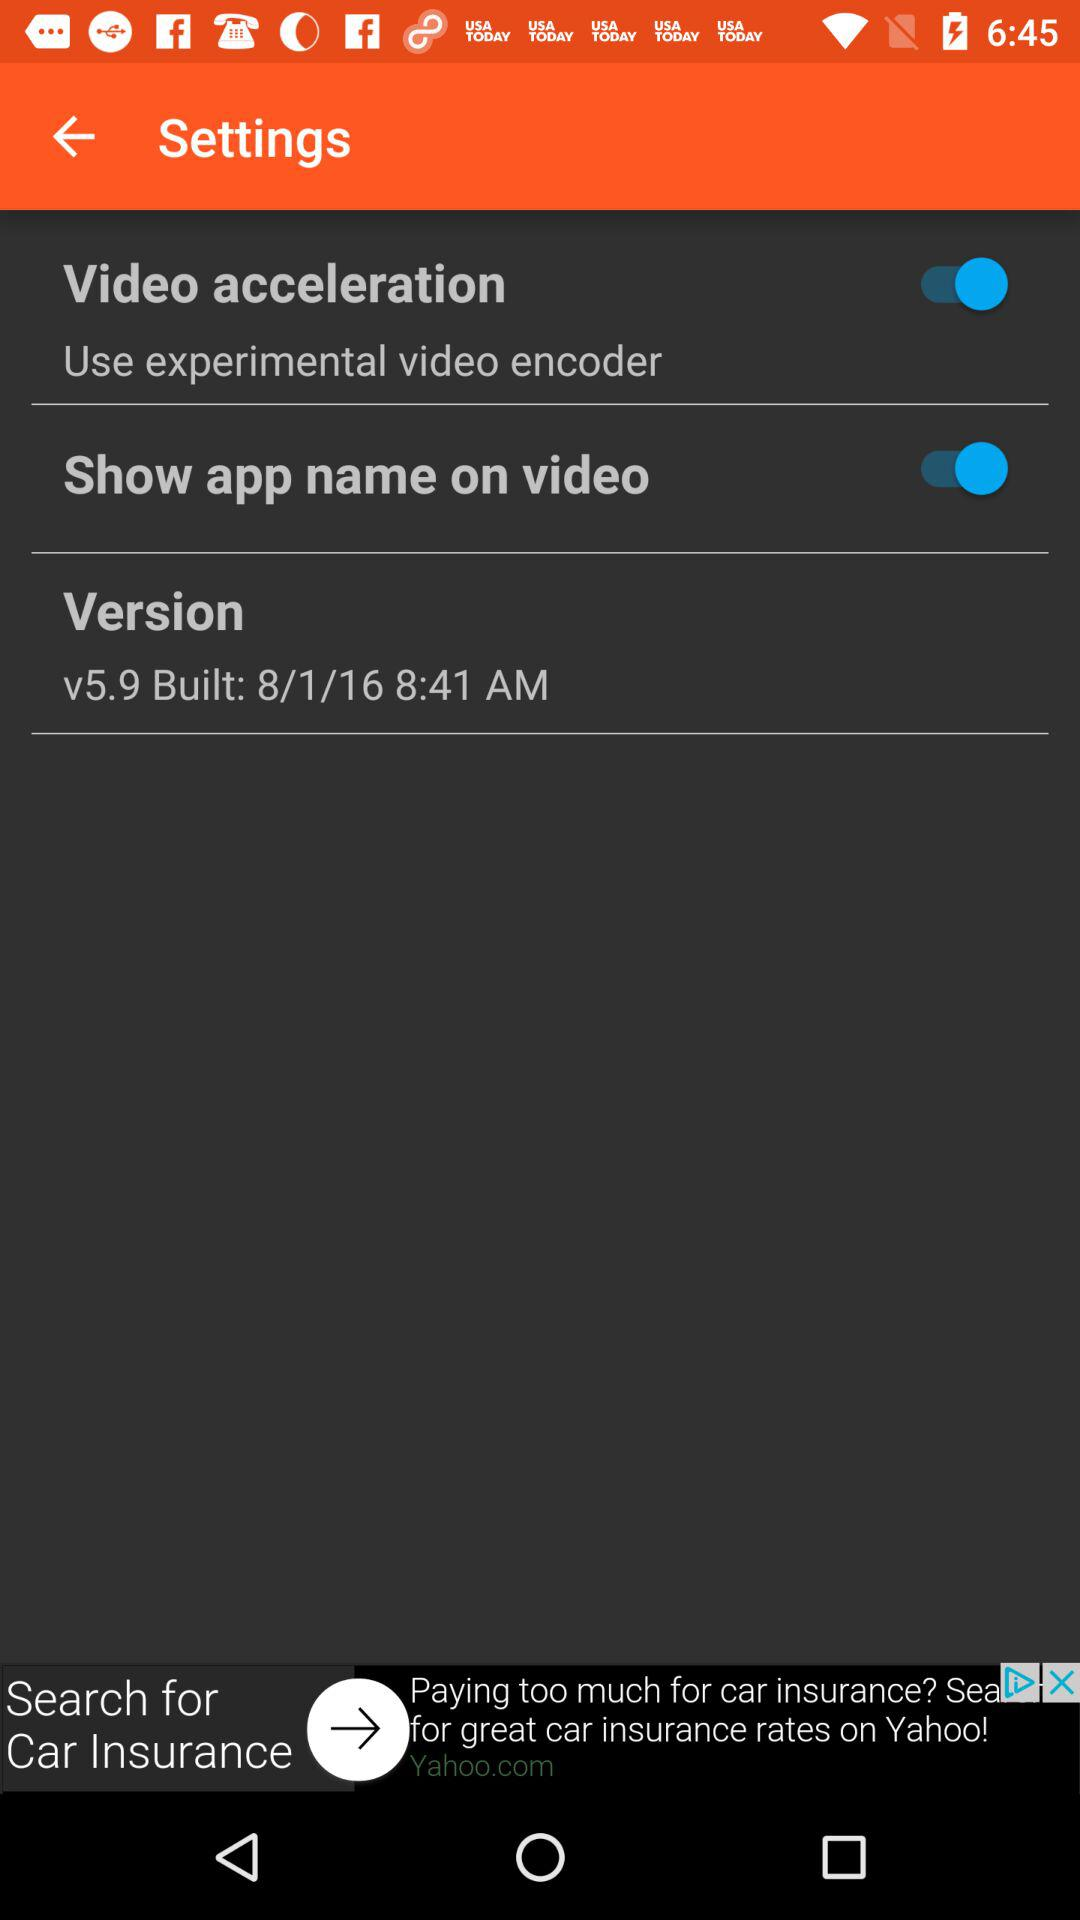How many items are in the settings menu?
Answer the question using a single word or phrase. 3 